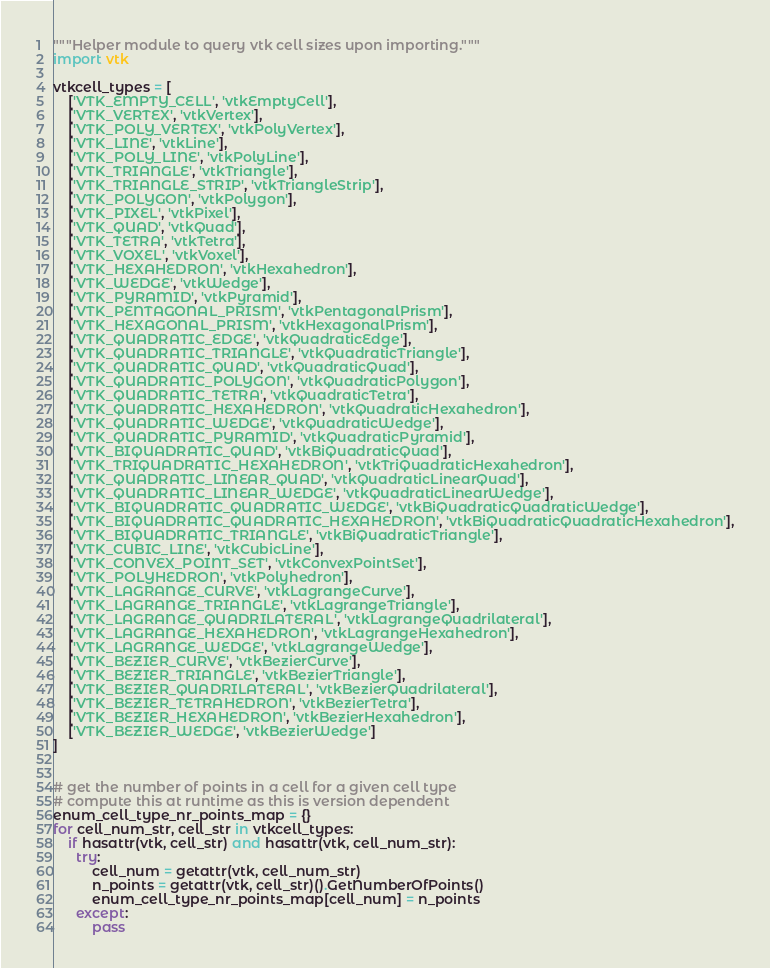Convert code to text. <code><loc_0><loc_0><loc_500><loc_500><_Python_>"""Helper module to query vtk cell sizes upon importing."""
import vtk

vtkcell_types = [
    ['VTK_EMPTY_CELL', 'vtkEmptyCell'],
    ['VTK_VERTEX', 'vtkVertex'],
    ['VTK_POLY_VERTEX', 'vtkPolyVertex'],
    ['VTK_LINE', 'vtkLine'],
    ['VTK_POLY_LINE', 'vtkPolyLine'],
    ['VTK_TRIANGLE', 'vtkTriangle'],
    ['VTK_TRIANGLE_STRIP', 'vtkTriangleStrip'],
    ['VTK_POLYGON', 'vtkPolygon'],
    ['VTK_PIXEL', 'vtkPixel'],
    ['VTK_QUAD', 'vtkQuad'],
    ['VTK_TETRA', 'vtkTetra'],
    ['VTK_VOXEL', 'vtkVoxel'],
    ['VTK_HEXAHEDRON', 'vtkHexahedron'],
    ['VTK_WEDGE', 'vtkWedge'],
    ['VTK_PYRAMID', 'vtkPyramid'],
    ['VTK_PENTAGONAL_PRISM', 'vtkPentagonalPrism'],
    ['VTK_HEXAGONAL_PRISM', 'vtkHexagonalPrism'],
    ['VTK_QUADRATIC_EDGE', 'vtkQuadraticEdge'],
    ['VTK_QUADRATIC_TRIANGLE', 'vtkQuadraticTriangle'],
    ['VTK_QUADRATIC_QUAD', 'vtkQuadraticQuad'],
    ['VTK_QUADRATIC_POLYGON', 'vtkQuadraticPolygon'],
    ['VTK_QUADRATIC_TETRA', 'vtkQuadraticTetra'],
    ['VTK_QUADRATIC_HEXAHEDRON', 'vtkQuadraticHexahedron'],
    ['VTK_QUADRATIC_WEDGE', 'vtkQuadraticWedge'],
    ['VTK_QUADRATIC_PYRAMID', 'vtkQuadraticPyramid'],
    ['VTK_BIQUADRATIC_QUAD', 'vtkBiQuadraticQuad'],
    ['VTK_TRIQUADRATIC_HEXAHEDRON', 'vtkTriQuadraticHexahedron'],
    ['VTK_QUADRATIC_LINEAR_QUAD', 'vtkQuadraticLinearQuad'],
    ['VTK_QUADRATIC_LINEAR_WEDGE', 'vtkQuadraticLinearWedge'],
    ['VTK_BIQUADRATIC_QUADRATIC_WEDGE', 'vtkBiQuadraticQuadraticWedge'],
    ['VTK_BIQUADRATIC_QUADRATIC_HEXAHEDRON', 'vtkBiQuadraticQuadraticHexahedron'],
    ['VTK_BIQUADRATIC_TRIANGLE', 'vtkBiQuadraticTriangle'],
    ['VTK_CUBIC_LINE', 'vtkCubicLine'],
    ['VTK_CONVEX_POINT_SET', 'vtkConvexPointSet'],
    ['VTK_POLYHEDRON', 'vtkPolyhedron'],
    ['VTK_LAGRANGE_CURVE', 'vtkLagrangeCurve'],
    ['VTK_LAGRANGE_TRIANGLE', 'vtkLagrangeTriangle'],
    ['VTK_LAGRANGE_QUADRILATERAL', 'vtkLagrangeQuadrilateral'],
    ['VTK_LAGRANGE_HEXAHEDRON', 'vtkLagrangeHexahedron'],
    ['VTK_LAGRANGE_WEDGE', 'vtkLagrangeWedge'],
    ['VTK_BEZIER_CURVE', 'vtkBezierCurve'],
    ['VTK_BEZIER_TRIANGLE', 'vtkBezierTriangle'],
    ['VTK_BEZIER_QUADRILATERAL', 'vtkBezierQuadrilateral'],
    ['VTK_BEZIER_TETRAHEDRON', 'vtkBezierTetra'],
    ['VTK_BEZIER_HEXAHEDRON', 'vtkBezierHexahedron'],
    ['VTK_BEZIER_WEDGE', 'vtkBezierWedge']
]


# get the number of points in a cell for a given cell type
# compute this at runtime as this is version dependent
enum_cell_type_nr_points_map = {}
for cell_num_str, cell_str in vtkcell_types:
    if hasattr(vtk, cell_str) and hasattr(vtk, cell_num_str):
      try:
          cell_num = getattr(vtk, cell_num_str)
          n_points = getattr(vtk, cell_str)().GetNumberOfPoints()
          enum_cell_type_nr_points_map[cell_num] = n_points
      except:
          pass
</code> 